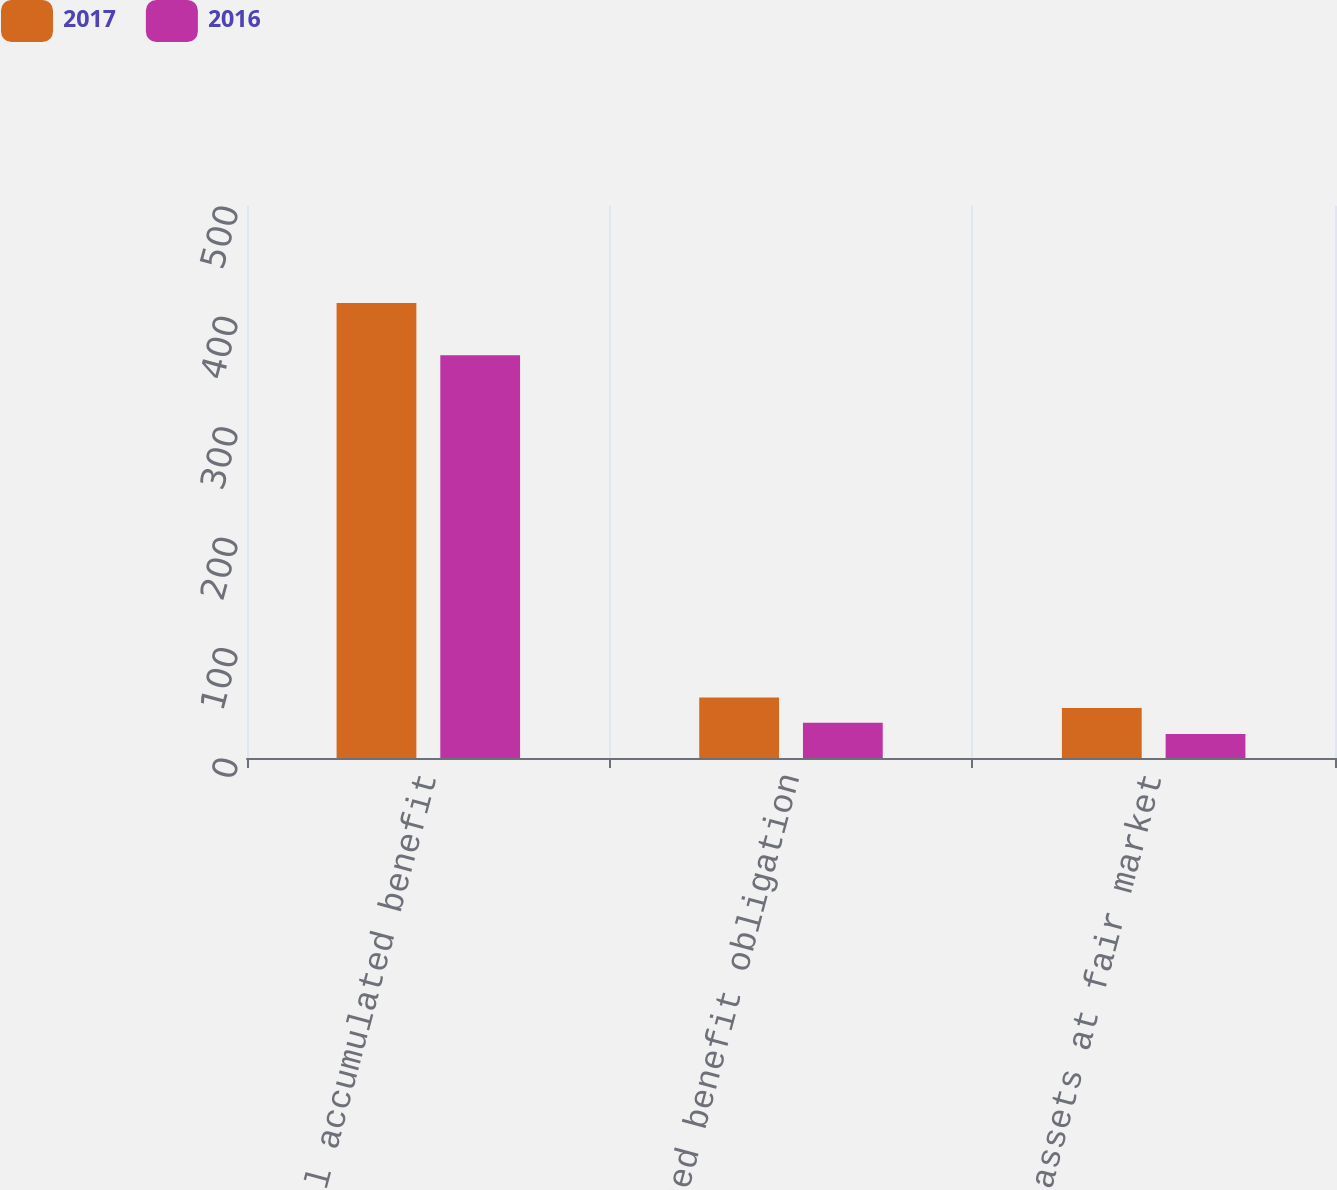<chart> <loc_0><loc_0><loc_500><loc_500><stacked_bar_chart><ecel><fcel>Total accumulated benefit<fcel>Accumulated benefit obligation<fcel>Plan assets at fair market<nl><fcel>2017<fcel>412.1<fcel>54.7<fcel>45.2<nl><fcel>2016<fcel>364.8<fcel>32<fcel>21.8<nl></chart> 